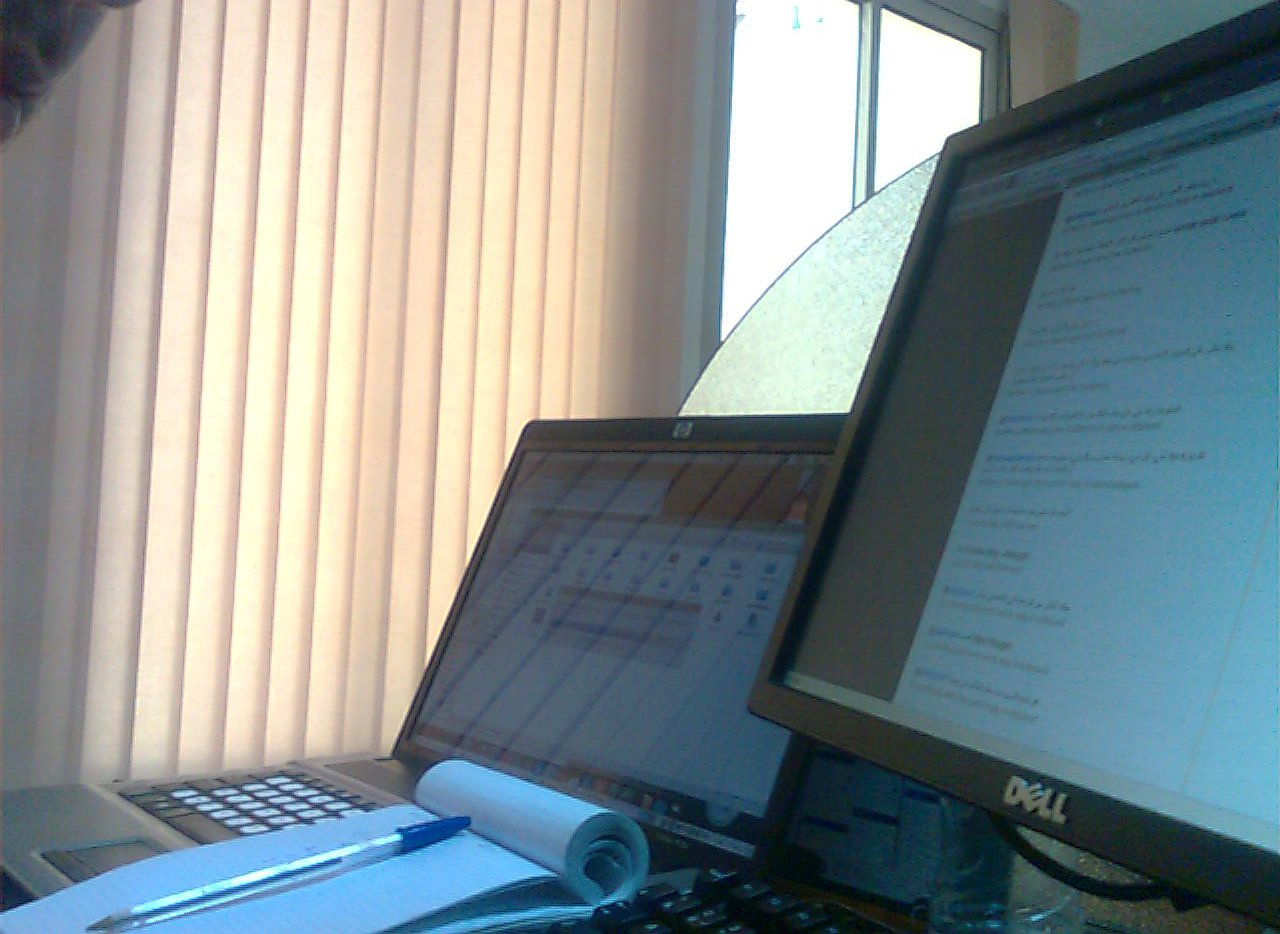Do the cap and the pen have different colors? No, both the cap and the pen share the same shade of blue. 